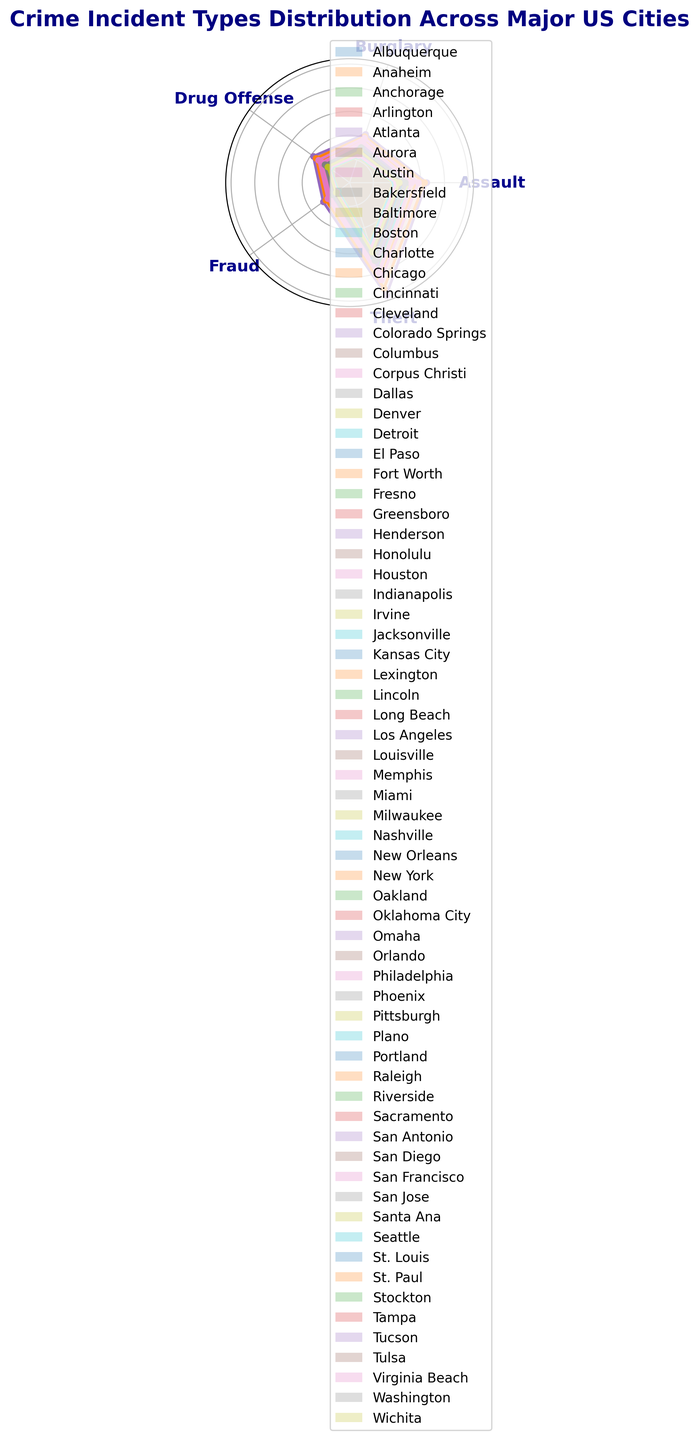Which city has the highest count of thefts? By examining the plot, we can see the length (or height) of the bars corresponding to ‘Theft’ for each city. The tallest bar in the ‘Theft’ category represents Los Angeles.
Answer: Los Angeles Which city has the least number of drug offenses? By checking the bars’ heights for the ‘Drug Offense’ category, the shortest bar is associated with Irvine.
Answer: Irvine Is the count of assaults in Chicago greater than in Houston? Observe the bars corresponding to ‘Assault’ for both cities and compare their heights. The bar for Chicago is taller than the one for Houston.
Answer: Yes What is the combined count of burglaries and assaults in New York? First, identify the lengths of the bars for ‘Burglary’ and ‘Assault’ in New York. Then, sum these counts: 1024 (Burglary) + 1578 (Assault).
Answer: 2602 Which city has a higher count of frauds, Denver or Detroit? Locate and compare the bar heights for ‘Fraud’ in Denver and Detroit. The bar for Detroit is taller.
Answer: Detroit Is the count of thefts in San Francisco less than in Philadelphia? Compare the heights of the bars for ‘Theft’ in both cities. San Francisco’s bar is shorter than Philadelphia’s.
Answer: Yes What is the total count of burglaries across Chicago and Los Angeles? Find the bars for ‘Burglary’ in both cities and sum their heights: 980 (Chicago) + 1075 (Los Angeles).
Answer: 2055 For the incident type 'Assault', which city ranks second highest? Examine the heights of the bars for ‘Assault’ across all cities. New York has the highest, and Los Angeles appears second highest.
Answer: Los Angeles What is the difference in the count of drug offenses between New York and Chicago? Find the bars for ‘Drug Offense’ in both cities and calculate the difference: 876 (New York) - 789 (Chicago).
Answer: 87 Which city has the highest count of frauds? Identify the longest bar in the ‘Fraud’ category. The highest count is associated with Los Angeles.
Answer: Los Angeles 